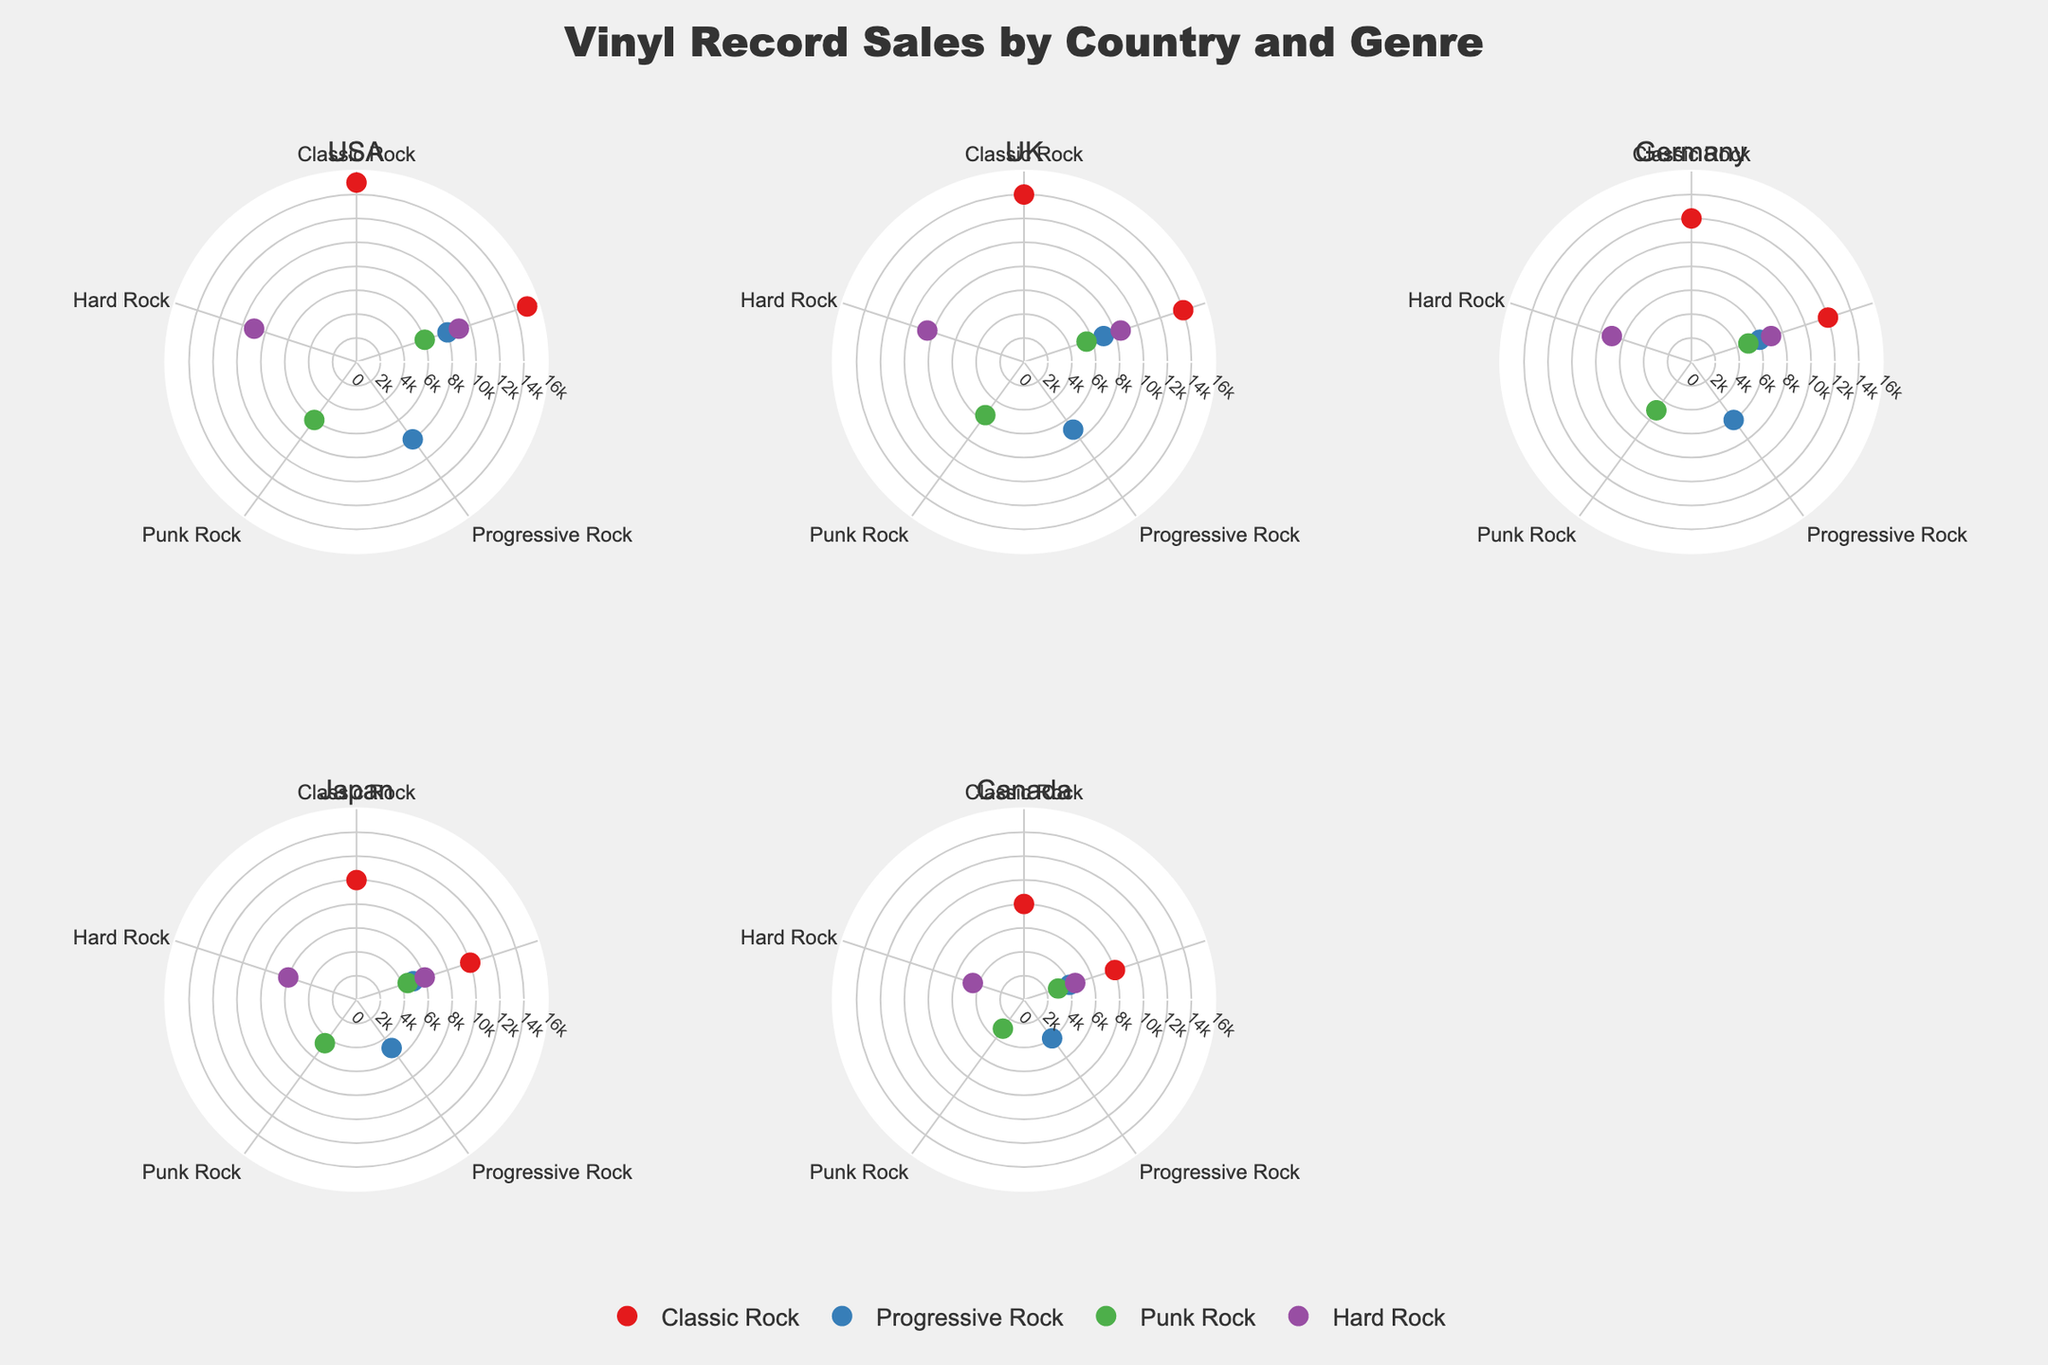What's the country with the highest sales in Classic Rock? Look at the Classic Rock data points for each subplot (country). The USA shows the highest value at 15,000.
Answer: USA How many countries are included in this figure? Count the number of subplot titles, which correspond to the countries. There are five countries in total.
Answer: 5 Which genre has the lowest sales in Japan? Check the sales values for each genre in the Japan subplot. Punk Rock has the lowest sales at 4,500.
Answer: Punk Rock What is the total sales of Hard Rock in the UK and Germany combined? Sum the sales values for Hard Rock in the UK (8,500) and Germany (7,000). The total is 8,500 + 7,000 = 15,500.
Answer: 15,500 Compare the sales of Progressive Rock in the USA and Canada. Which country has higher sales? Look at the Progressive Rock sales data points for the USA (8,000) and Canada (4,000). The USA has higher sales.
Answer: USA What's the average sales value of Classic Rock across all countries? Compute the average by summing the Classic Rock sales values for all countries (15,000 + 14,000 + 12,000 + 10,000 + 8,000) and divide by the number of countries (5). The average is (15,000 + 14,000 + 12,000 + 10,000 + 8,000) / 5 = 11,800.
Answer: 11,800 Which genre has the most variation in sales across countries? Identify the genre with the widest range in sales values across all countries. Classic Rock ranges from 8,000 to 15,000, which is the largest variation of 7,000.
Answer: Classic Rock In which country does Progressive Rock have the least amount of sales? Check the Progressive Rock sales values for each country. Canada has the least at 4,000.
Answer: Canada Which genre is consistently least popular across all countries? Identify the genre with lower sales values most consistently across the countries. Punk Rock has the lowest sales in several countries, with values like 6,000 (USA), 5,500 (UK), 5,000 (Germany), 4,500 (Japan), and 3,000 (Canada).
Answer: Punk Rock 